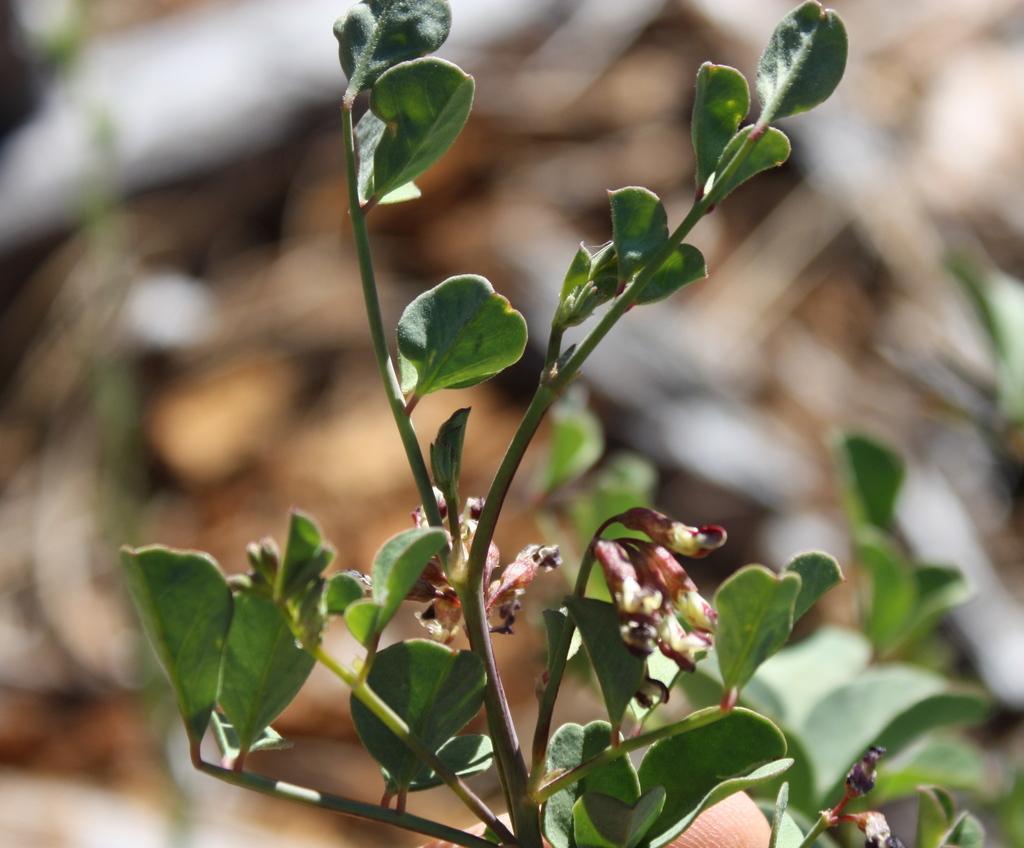In one or two sentences, can you explain what this image depicts? In this picture we can see a few leaves and stems. Background is blurry. 